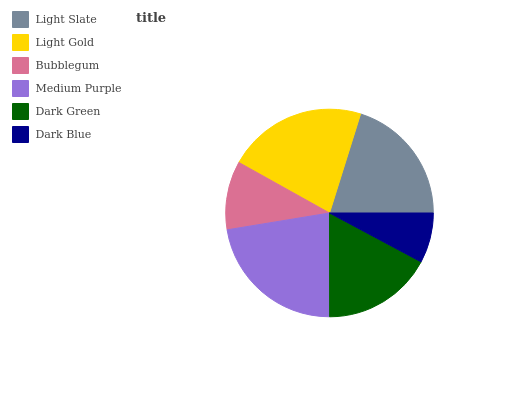Is Dark Blue the minimum?
Answer yes or no. Yes. Is Medium Purple the maximum?
Answer yes or no. Yes. Is Light Gold the minimum?
Answer yes or no. No. Is Light Gold the maximum?
Answer yes or no. No. Is Light Gold greater than Light Slate?
Answer yes or no. Yes. Is Light Slate less than Light Gold?
Answer yes or no. Yes. Is Light Slate greater than Light Gold?
Answer yes or no. No. Is Light Gold less than Light Slate?
Answer yes or no. No. Is Light Slate the high median?
Answer yes or no. Yes. Is Dark Green the low median?
Answer yes or no. Yes. Is Medium Purple the high median?
Answer yes or no. No. Is Bubblegum the low median?
Answer yes or no. No. 